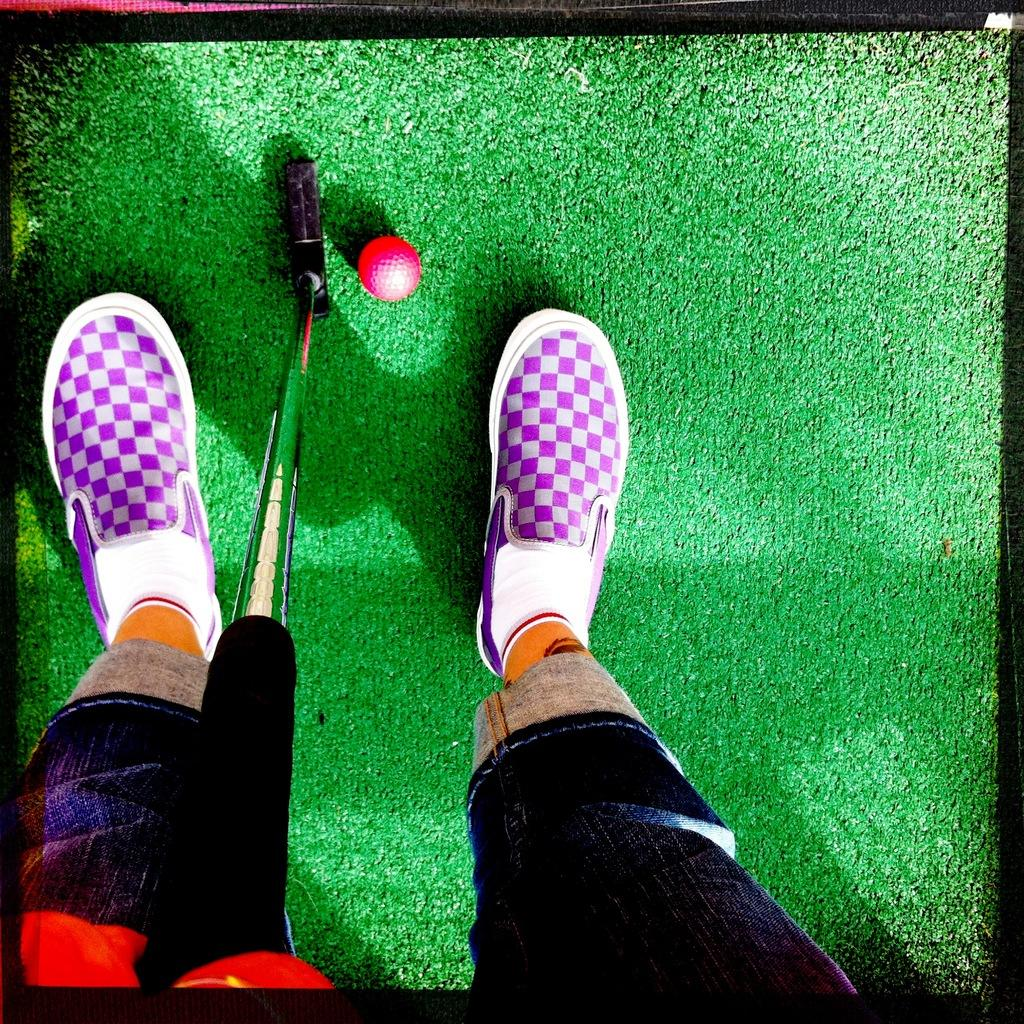What is the main subject of the image? There is a person in the image. What is the person doing in the image? The person is standing on the ground and holding a billiards stick. Are there any objects on the ground in the image? Yes, there is a ball on the ground. What type of trousers is the person wearing in the image? The provided facts do not mention the type of trousers the person is wearing, so we cannot answer this question definitively. How does the ball move around in the image? The ball does not move around in the image; it is stationary on the ground. 